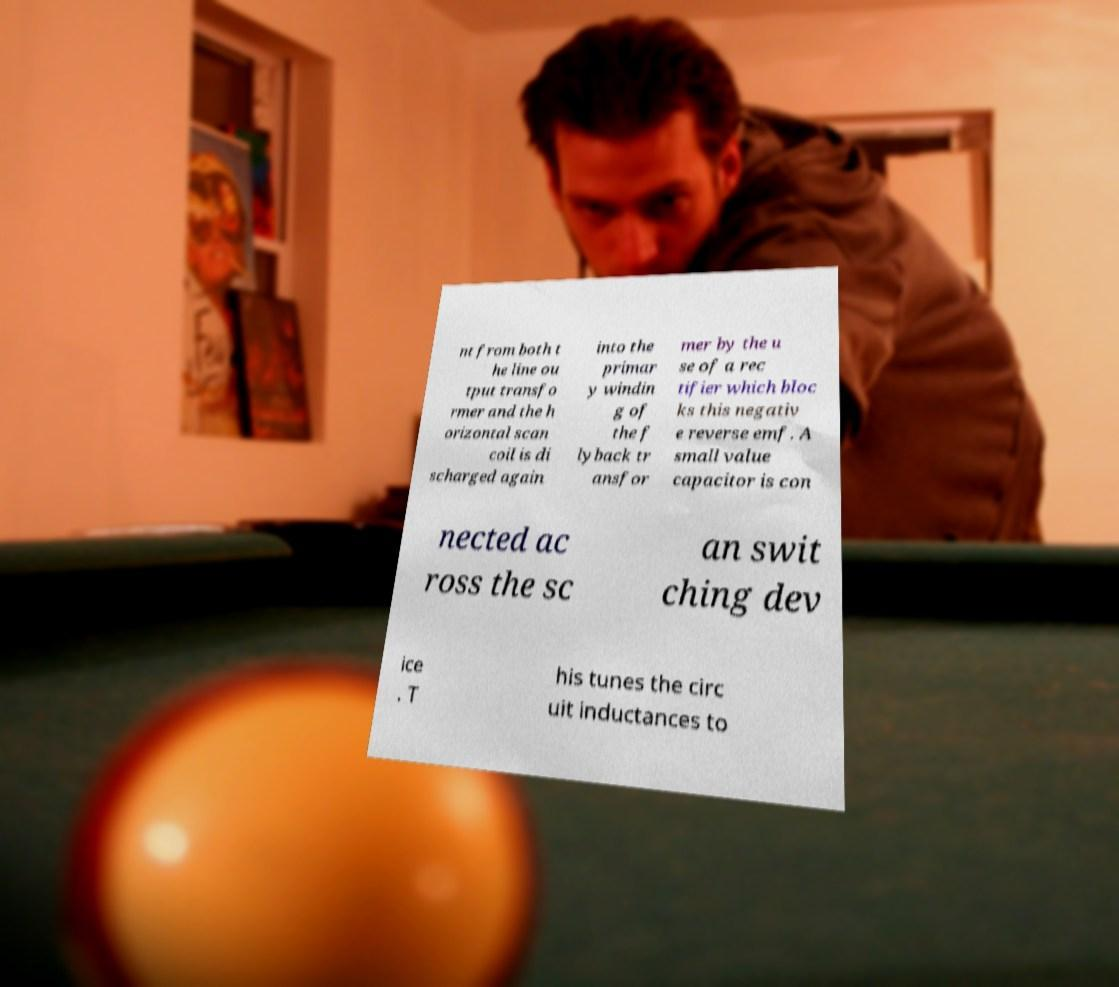Could you assist in decoding the text presented in this image and type it out clearly? nt from both t he line ou tput transfo rmer and the h orizontal scan coil is di scharged again into the primar y windin g of the f lyback tr ansfor mer by the u se of a rec tifier which bloc ks this negativ e reverse emf. A small value capacitor is con nected ac ross the sc an swit ching dev ice . T his tunes the circ uit inductances to 